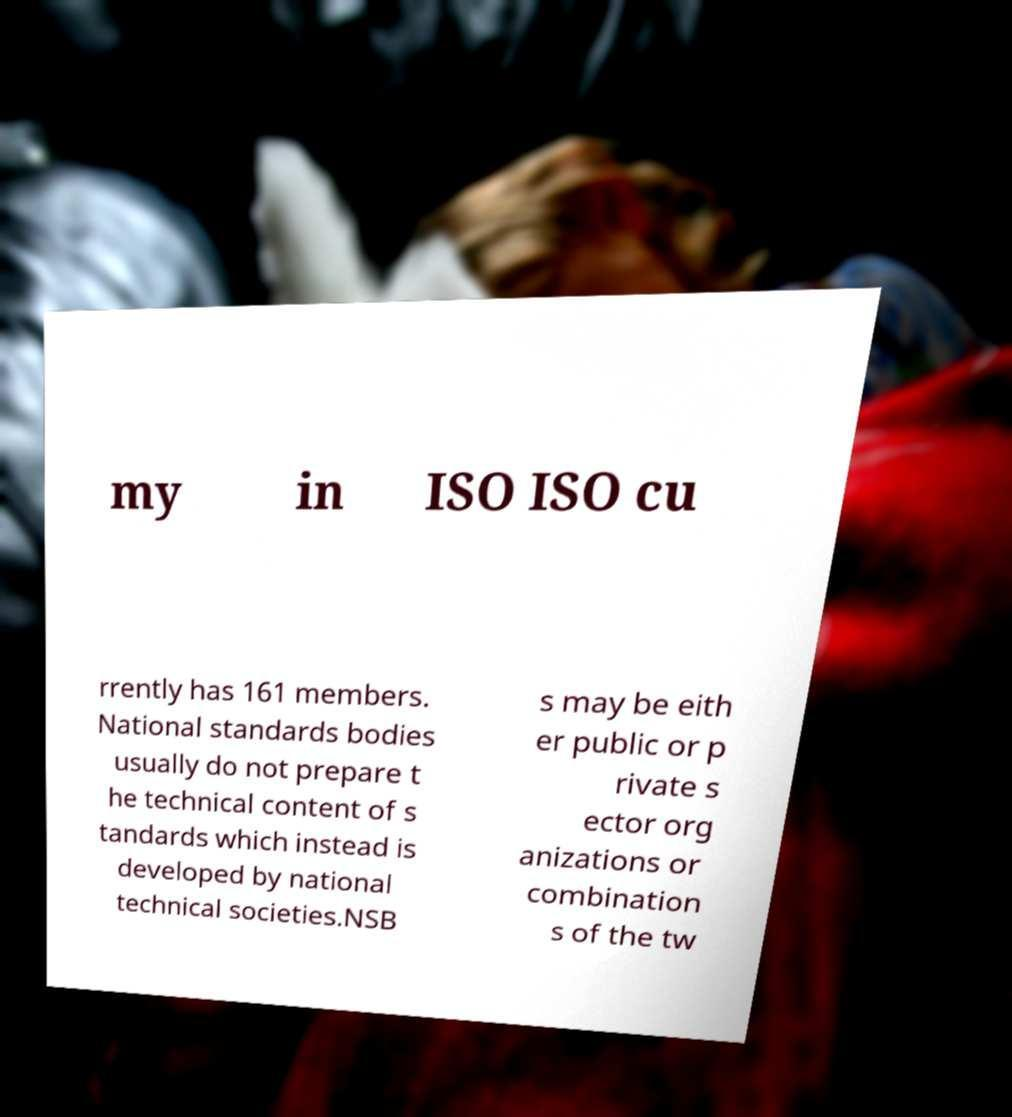Can you accurately transcribe the text from the provided image for me? my in ISO ISO cu rrently has 161 members. National standards bodies usually do not prepare t he technical content of s tandards which instead is developed by national technical societies.NSB s may be eith er public or p rivate s ector org anizations or combination s of the tw 